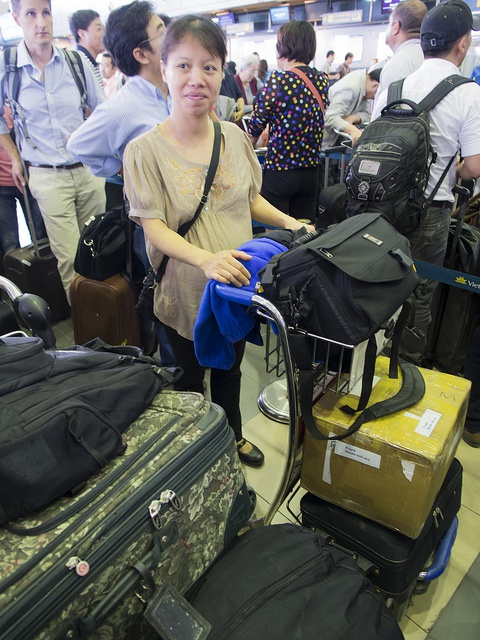Describe the objects in this image and their specific colors. I can see suitcase in lightgray, black, gray, olive, and darkgreen tones, people in lightgray, tan, and black tones, backpack in lightgray, black, and gray tones, suitcase in lightgray, black, gray, and darkgreen tones, and handbag in lightgray, black, gray, and darkgreen tones in this image. 